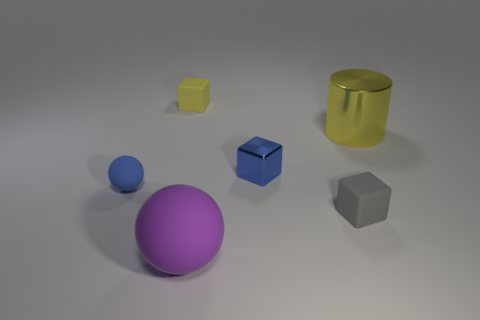Do the large object that is in front of the small gray cube and the shiny thing to the left of the large yellow cylinder have the same shape? no 